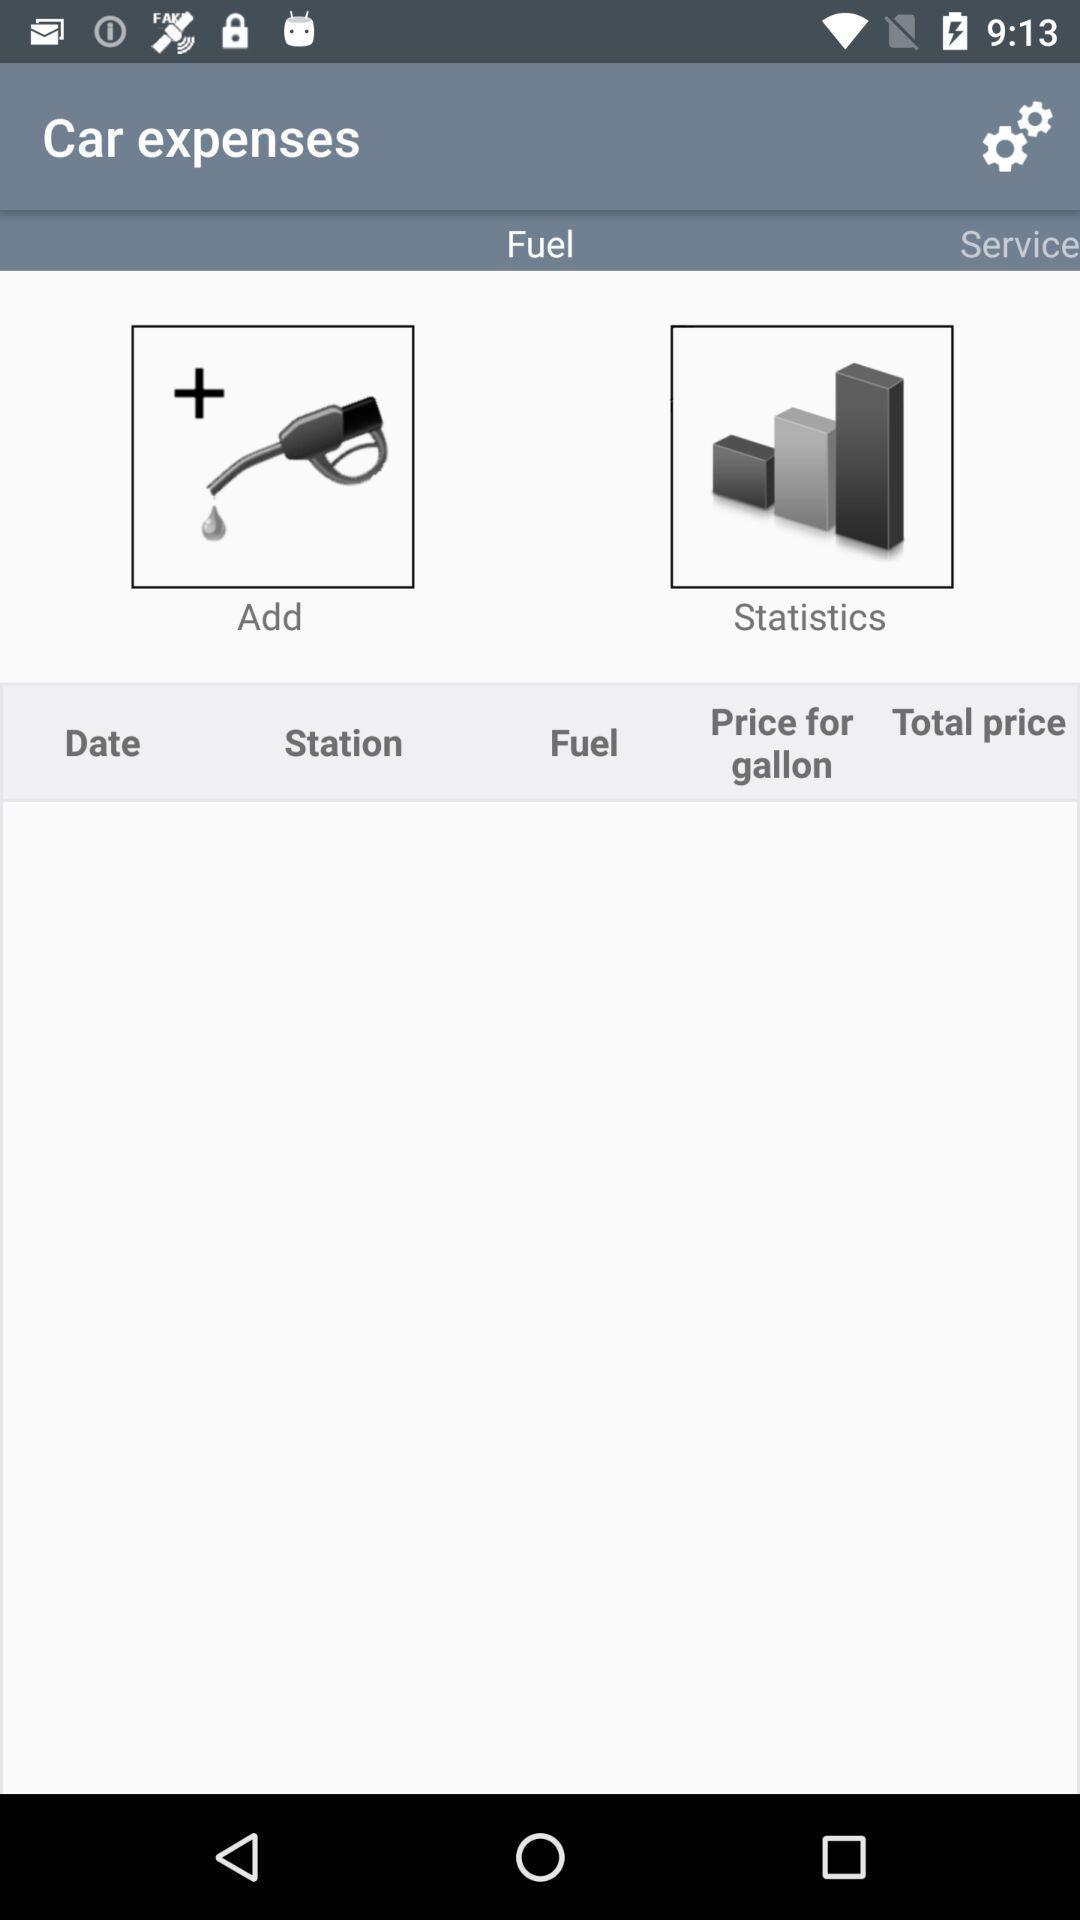Summarize the information in this screenshot. Page shows car expenses with few options in service application. 